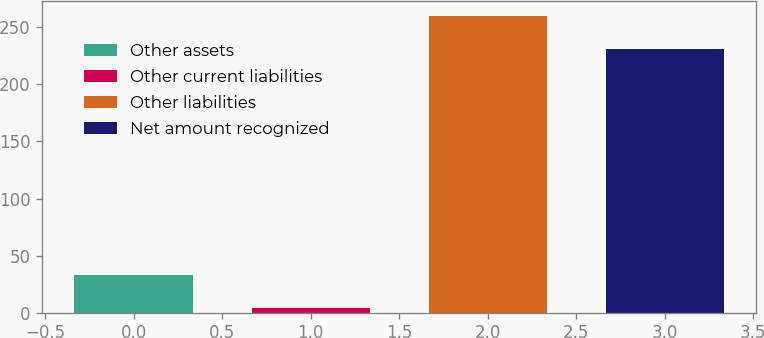Convert chart to OTSL. <chart><loc_0><loc_0><loc_500><loc_500><bar_chart><fcel>Other assets<fcel>Other current liabilities<fcel>Other liabilities<fcel>Net amount recognized<nl><fcel>33.4<fcel>4.5<fcel>260.1<fcel>231.2<nl></chart> 